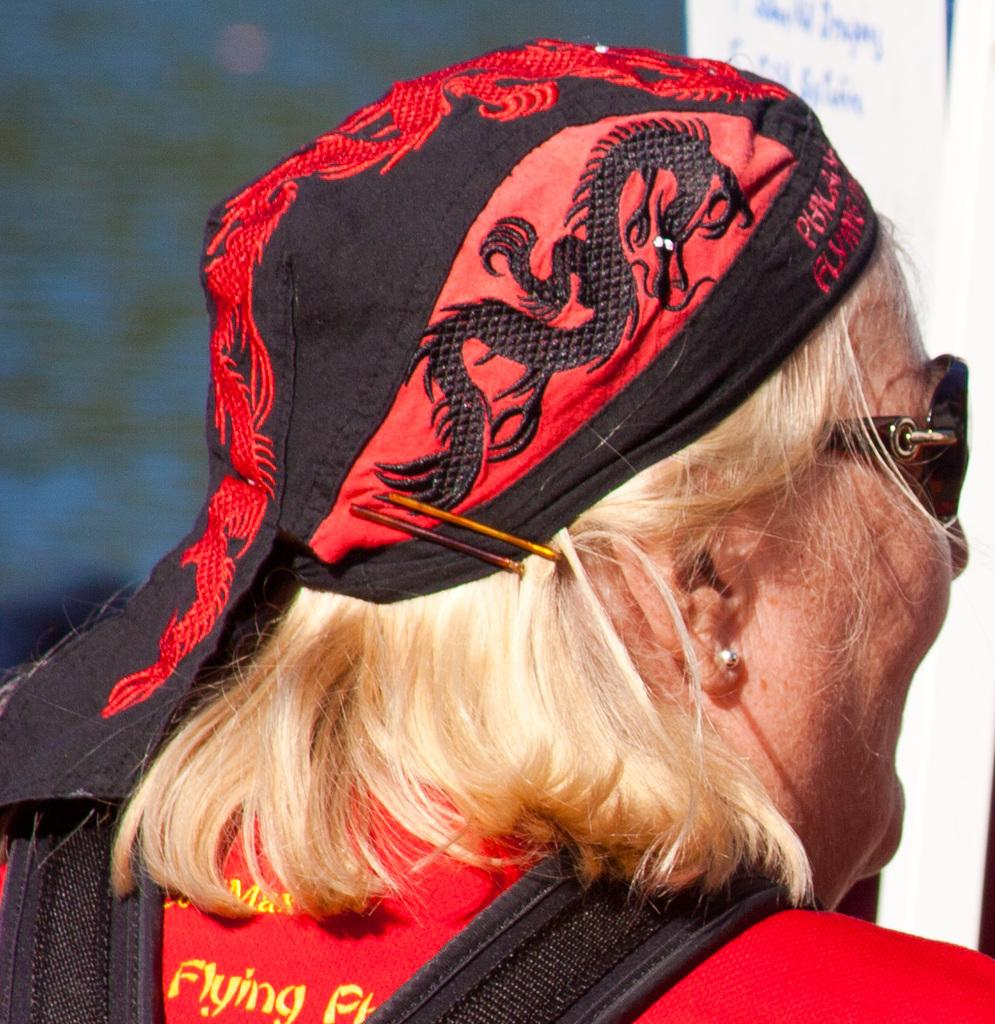What can be seen in the image? There is a person in the image. What is the person wearing on their head? The person has cloth on their head. What type of eyewear is the person wearing? The person is wearing goggles. What is the person carrying on their shoulders? The person has a bag on their shoulders. How would you describe the background of the image? The background of the image is blurred, but there are objects visible in it. What type of disease is the person suffering from in the image? There is no indication of any disease in the image; the person is simply wearing goggles and a cloth on their head. 